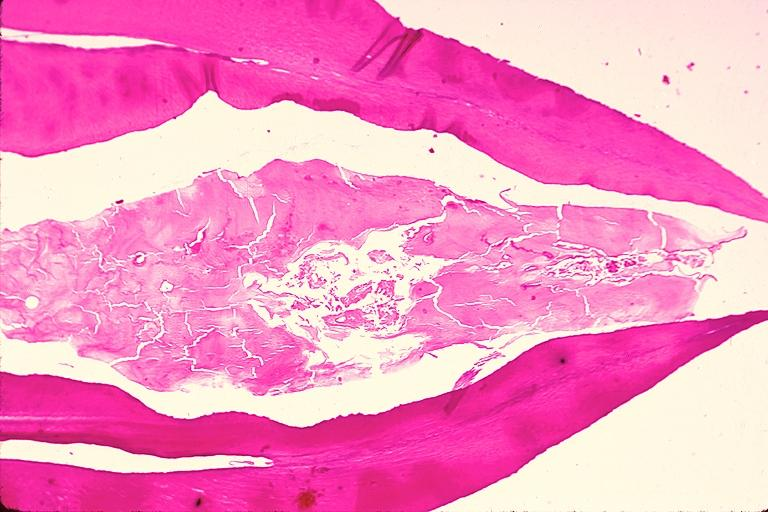where is this?
Answer the question using a single word or phrase. Oral 